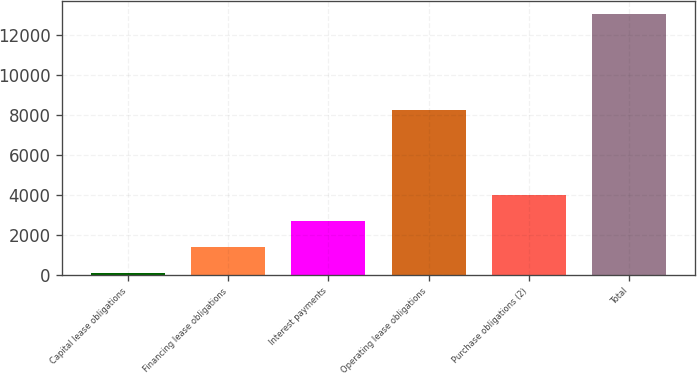<chart> <loc_0><loc_0><loc_500><loc_500><bar_chart><fcel>Capital lease obligations<fcel>Financing lease obligations<fcel>Interest payments<fcel>Operating lease obligations<fcel>Purchase obligations (2)<fcel>Total<nl><fcel>79<fcel>1376.5<fcel>2674<fcel>8247<fcel>3971.5<fcel>13054<nl></chart> 